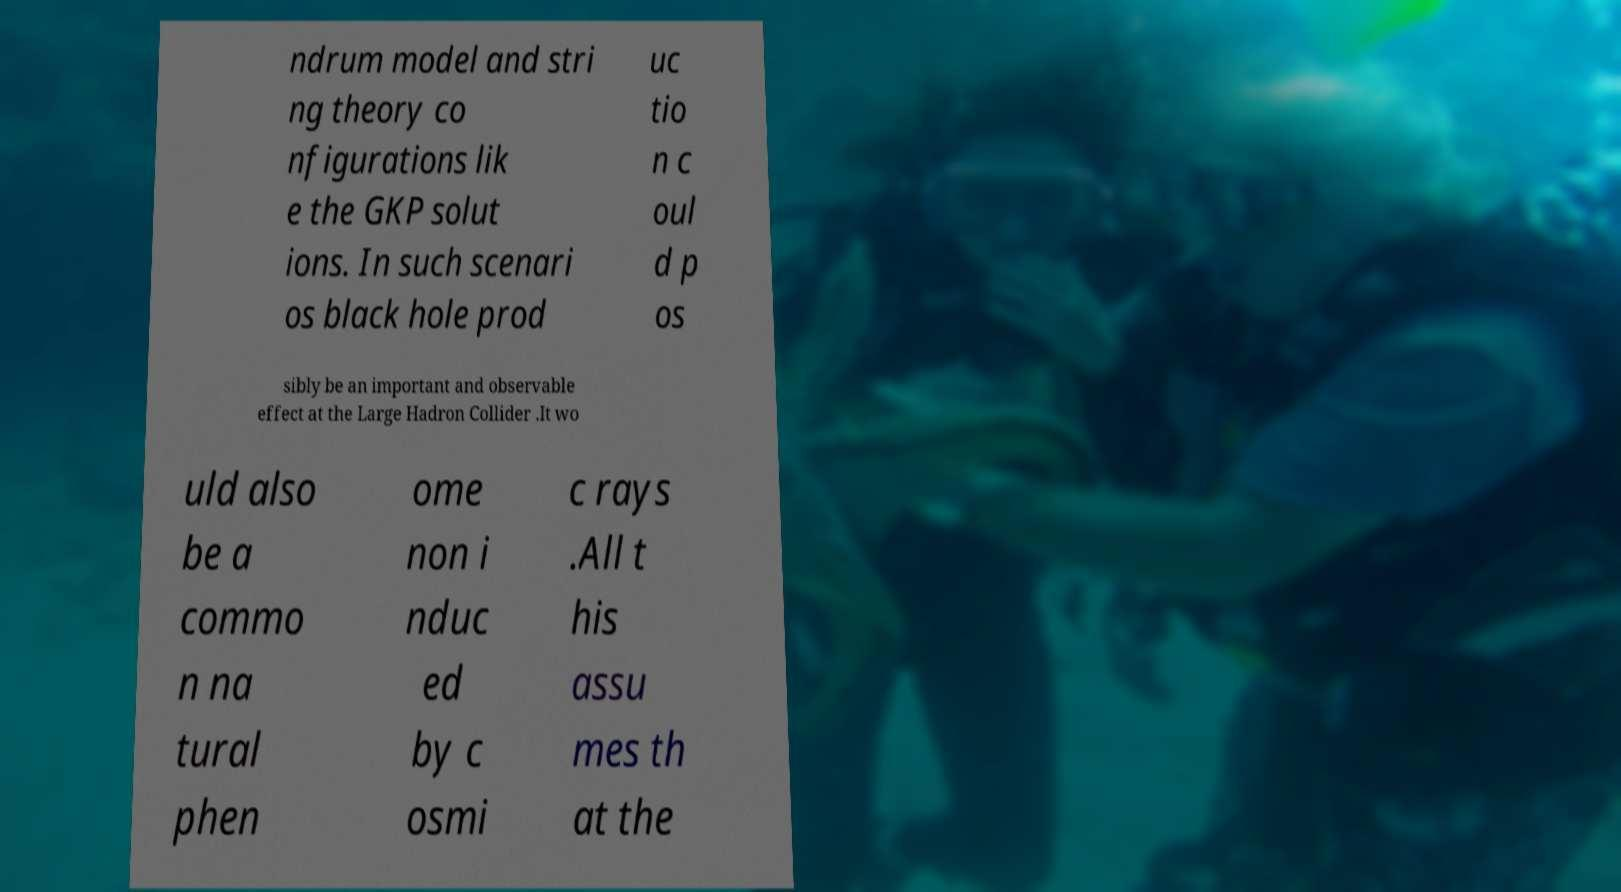Please identify and transcribe the text found in this image. ndrum model and stri ng theory co nfigurations lik e the GKP solut ions. In such scenari os black hole prod uc tio n c oul d p os sibly be an important and observable effect at the Large Hadron Collider .It wo uld also be a commo n na tural phen ome non i nduc ed by c osmi c rays .All t his assu mes th at the 